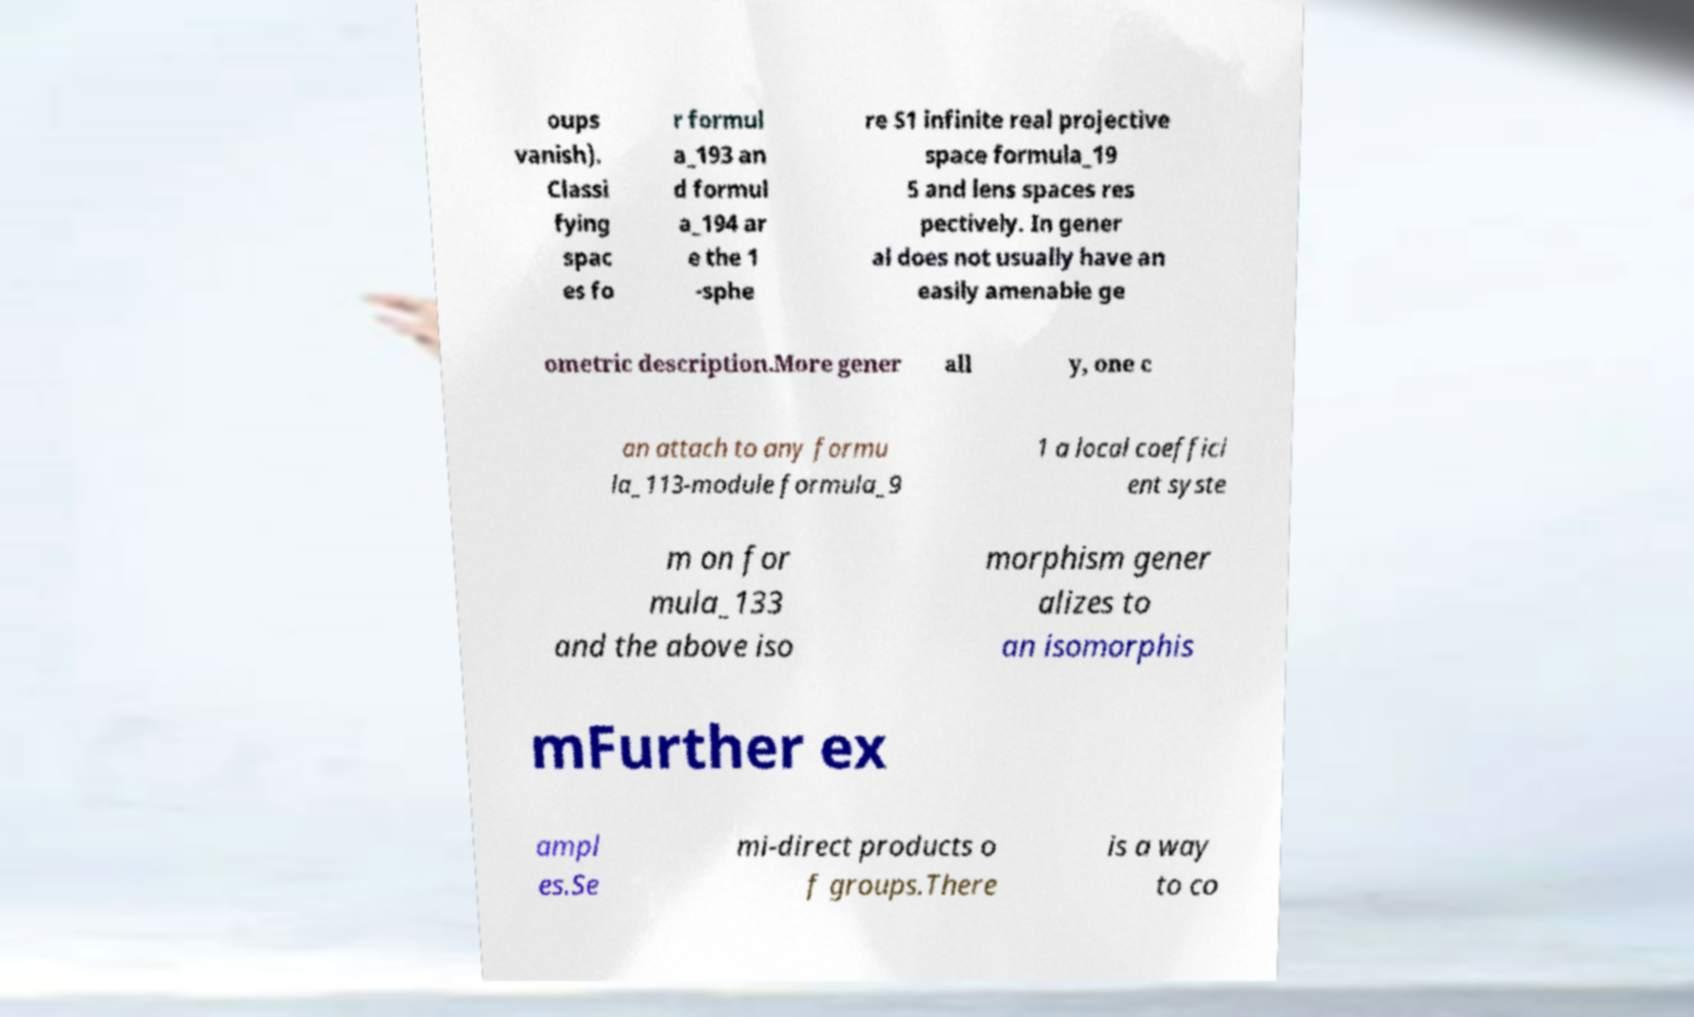There's text embedded in this image that I need extracted. Can you transcribe it verbatim? oups vanish). Classi fying spac es fo r formul a_193 an d formul a_194 ar e the 1 -sphe re S1 infinite real projective space formula_19 5 and lens spaces res pectively. In gener al does not usually have an easily amenable ge ometric description.More gener all y, one c an attach to any formu la_113-module formula_9 1 a local coeffici ent syste m on for mula_133 and the above iso morphism gener alizes to an isomorphis mFurther ex ampl es.Se mi-direct products o f groups.There is a way to co 